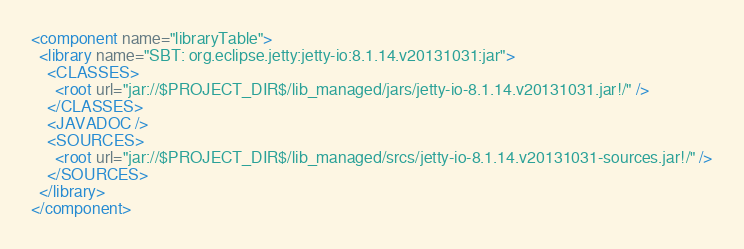Convert code to text. <code><loc_0><loc_0><loc_500><loc_500><_XML_><component name="libraryTable">
  <library name="SBT: org.eclipse.jetty:jetty-io:8.1.14.v20131031:jar">
    <CLASSES>
      <root url="jar://$PROJECT_DIR$/lib_managed/jars/jetty-io-8.1.14.v20131031.jar!/" />
    </CLASSES>
    <JAVADOC />
    <SOURCES>
      <root url="jar://$PROJECT_DIR$/lib_managed/srcs/jetty-io-8.1.14.v20131031-sources.jar!/" />
    </SOURCES>
  </library>
</component></code> 